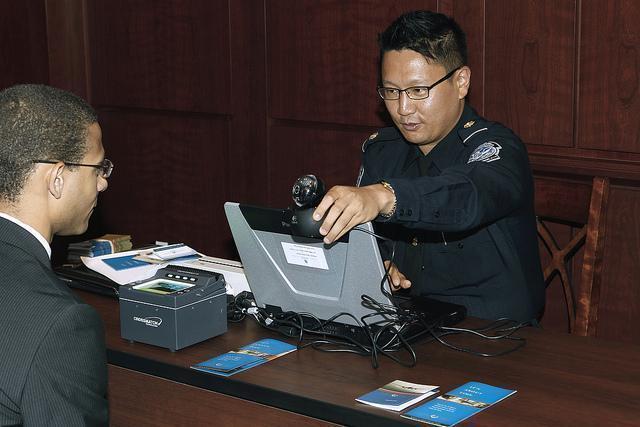What is the person with the laptop taking?
Select the correct answer and articulate reasoning with the following format: 'Answer: answer
Rationale: rationale.'
Options: Dictation, photograph, autographs, memo. Answer: photograph.
Rationale: He is taking a picture of the person in front of him. 